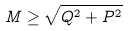<formula> <loc_0><loc_0><loc_500><loc_500>M \geq \sqrt { Q ^ { 2 } + P ^ { 2 } }</formula> 